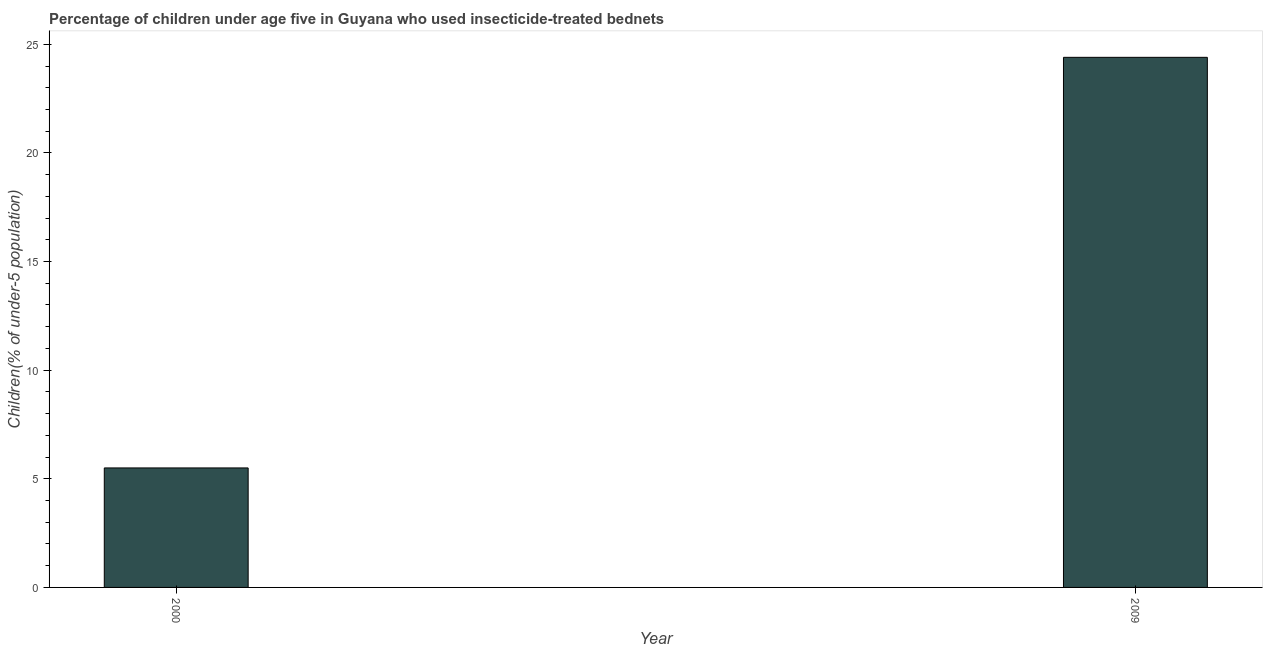Does the graph contain any zero values?
Make the answer very short. No. Does the graph contain grids?
Offer a very short reply. No. What is the title of the graph?
Ensure brevity in your answer.  Percentage of children under age five in Guyana who used insecticide-treated bednets. What is the label or title of the X-axis?
Offer a terse response. Year. What is the label or title of the Y-axis?
Your answer should be very brief. Children(% of under-5 population). What is the percentage of children who use of insecticide-treated bed nets in 2009?
Your answer should be very brief. 24.4. Across all years, what is the maximum percentage of children who use of insecticide-treated bed nets?
Offer a terse response. 24.4. Across all years, what is the minimum percentage of children who use of insecticide-treated bed nets?
Ensure brevity in your answer.  5.5. In which year was the percentage of children who use of insecticide-treated bed nets maximum?
Your answer should be compact. 2009. What is the sum of the percentage of children who use of insecticide-treated bed nets?
Offer a very short reply. 29.9. What is the difference between the percentage of children who use of insecticide-treated bed nets in 2000 and 2009?
Your answer should be very brief. -18.9. What is the average percentage of children who use of insecticide-treated bed nets per year?
Your answer should be very brief. 14.95. What is the median percentage of children who use of insecticide-treated bed nets?
Provide a short and direct response. 14.95. In how many years, is the percentage of children who use of insecticide-treated bed nets greater than 10 %?
Keep it short and to the point. 1. What is the ratio of the percentage of children who use of insecticide-treated bed nets in 2000 to that in 2009?
Give a very brief answer. 0.23. Is the percentage of children who use of insecticide-treated bed nets in 2000 less than that in 2009?
Provide a succinct answer. Yes. How many years are there in the graph?
Provide a succinct answer. 2. What is the difference between two consecutive major ticks on the Y-axis?
Give a very brief answer. 5. What is the Children(% of under-5 population) in 2009?
Give a very brief answer. 24.4. What is the difference between the Children(% of under-5 population) in 2000 and 2009?
Make the answer very short. -18.9. What is the ratio of the Children(% of under-5 population) in 2000 to that in 2009?
Provide a short and direct response. 0.23. 